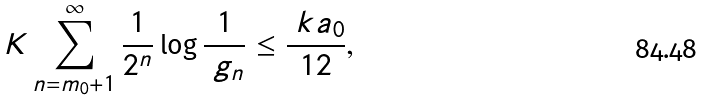Convert formula to latex. <formula><loc_0><loc_0><loc_500><loc_500>K \sum _ { n = m _ { 0 } + 1 } ^ { \infty } \frac { 1 } { 2 ^ { n } } \log \frac { 1 } { \ g _ { n } } \leq \frac { \ k a _ { 0 } } { 1 2 } ,</formula> 